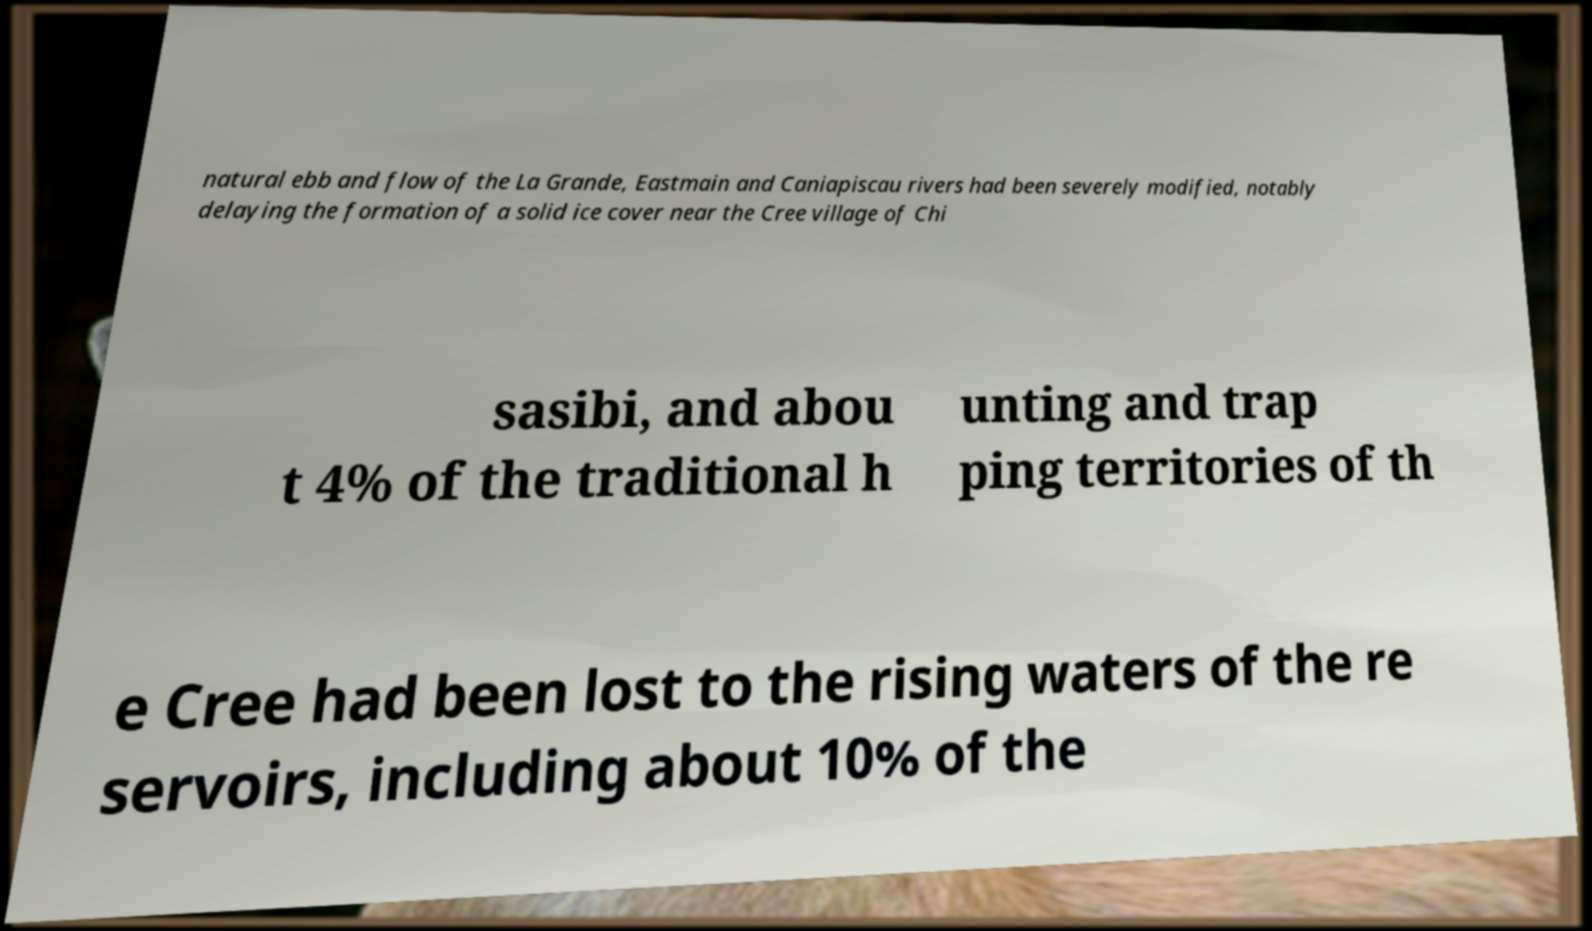Please identify and transcribe the text found in this image. natural ebb and flow of the La Grande, Eastmain and Caniapiscau rivers had been severely modified, notably delaying the formation of a solid ice cover near the Cree village of Chi sasibi, and abou t 4% of the traditional h unting and trap ping territories of th e Cree had been lost to the rising waters of the re servoirs, including about 10% of the 